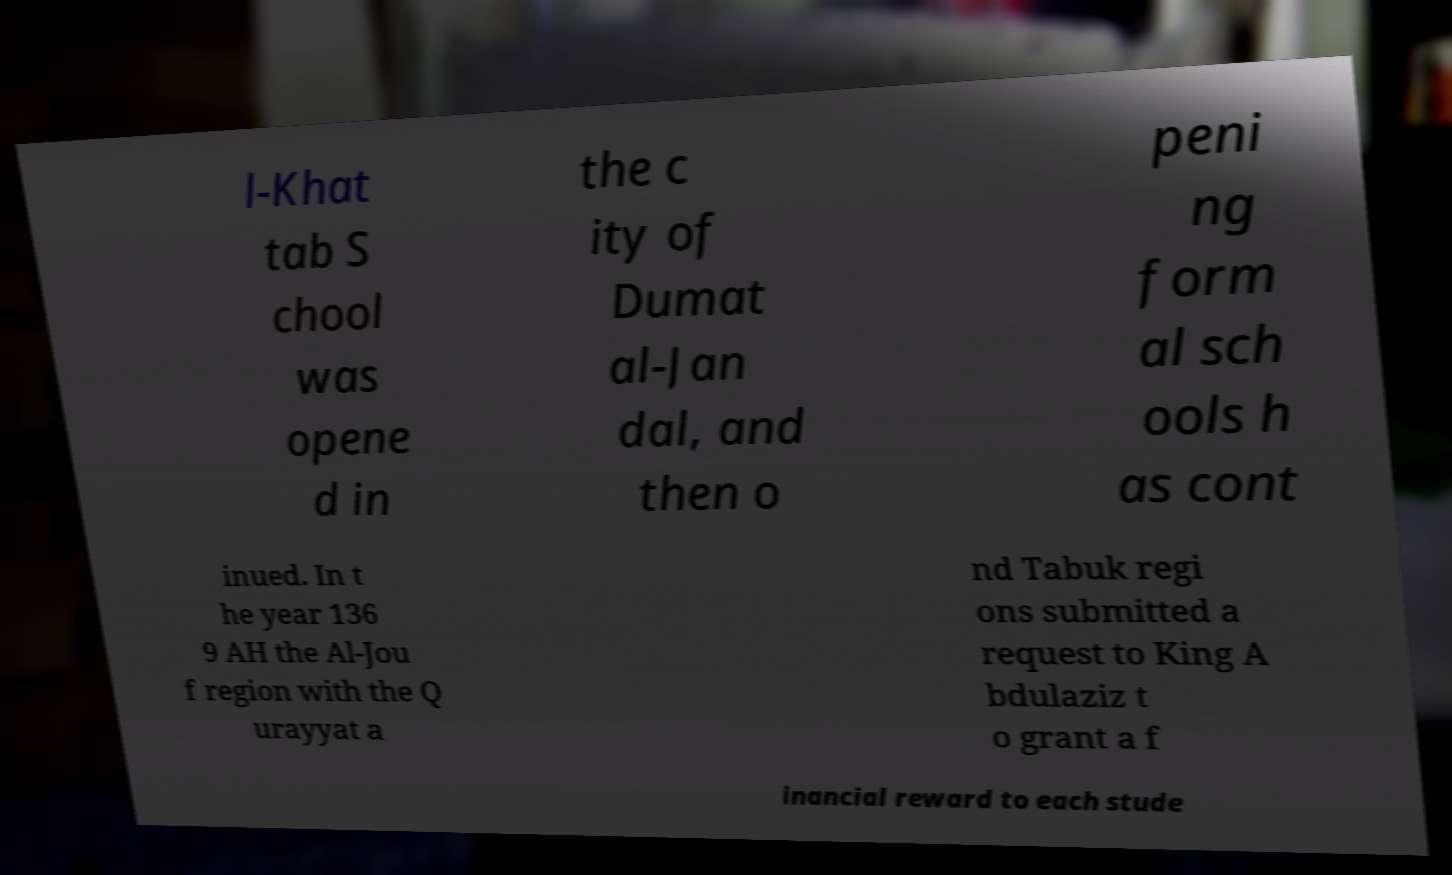Could you extract and type out the text from this image? l-Khat tab S chool was opene d in the c ity of Dumat al-Jan dal, and then o peni ng form al sch ools h as cont inued. In t he year 136 9 AH the Al-Jou f region with the Q urayyat a nd Tabuk regi ons submitted a request to King A bdulaziz t o grant a f inancial reward to each stude 